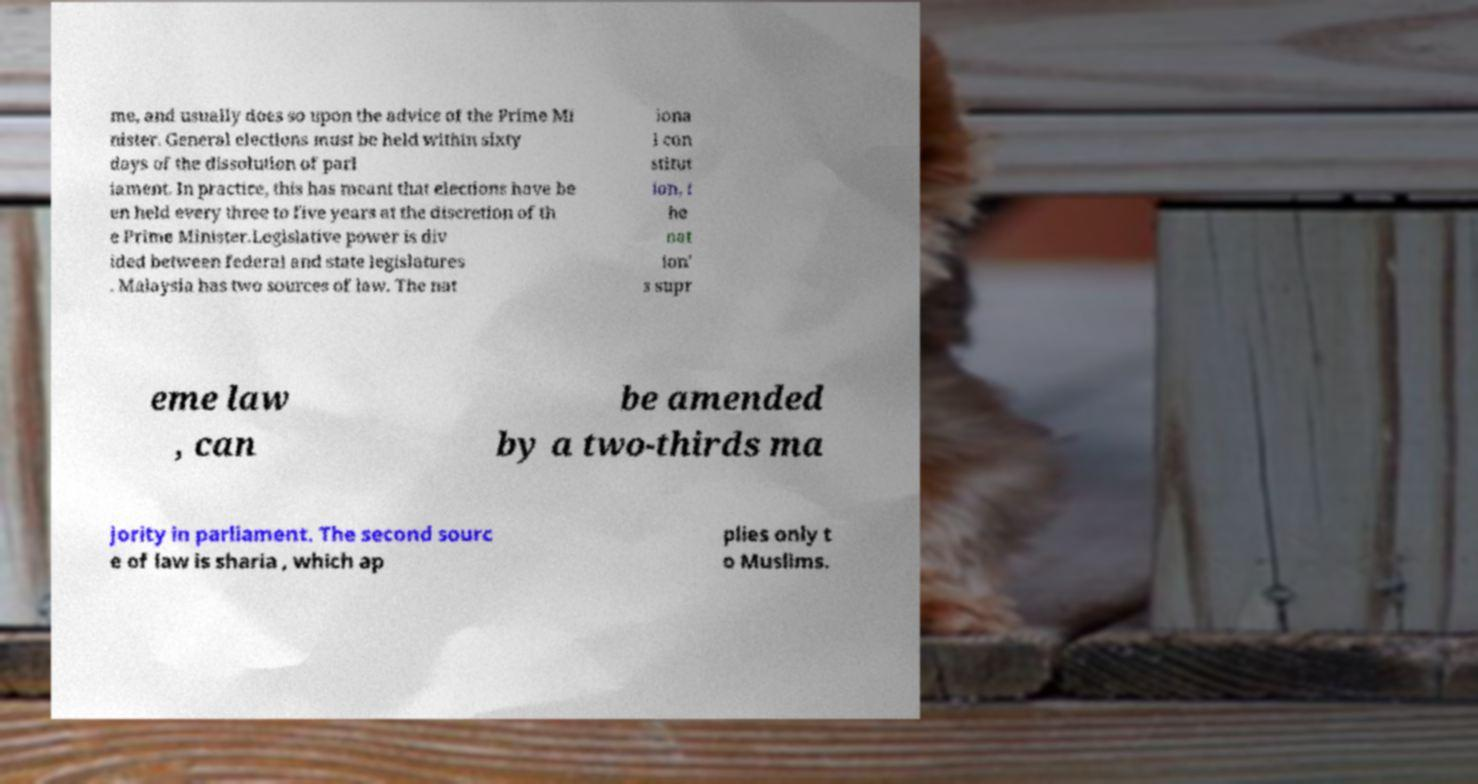I need the written content from this picture converted into text. Can you do that? me, and usually does so upon the advice of the Prime Mi nister. General elections must be held within sixty days of the dissolution of parl iament. In practice, this has meant that elections have be en held every three to five years at the discretion of th e Prime Minister.Legislative power is div ided between federal and state legislatures . Malaysia has two sources of law. The nat iona l con stitut ion, t he nat ion' s supr eme law , can be amended by a two-thirds ma jority in parliament. The second sourc e of law is sharia , which ap plies only t o Muslims. 